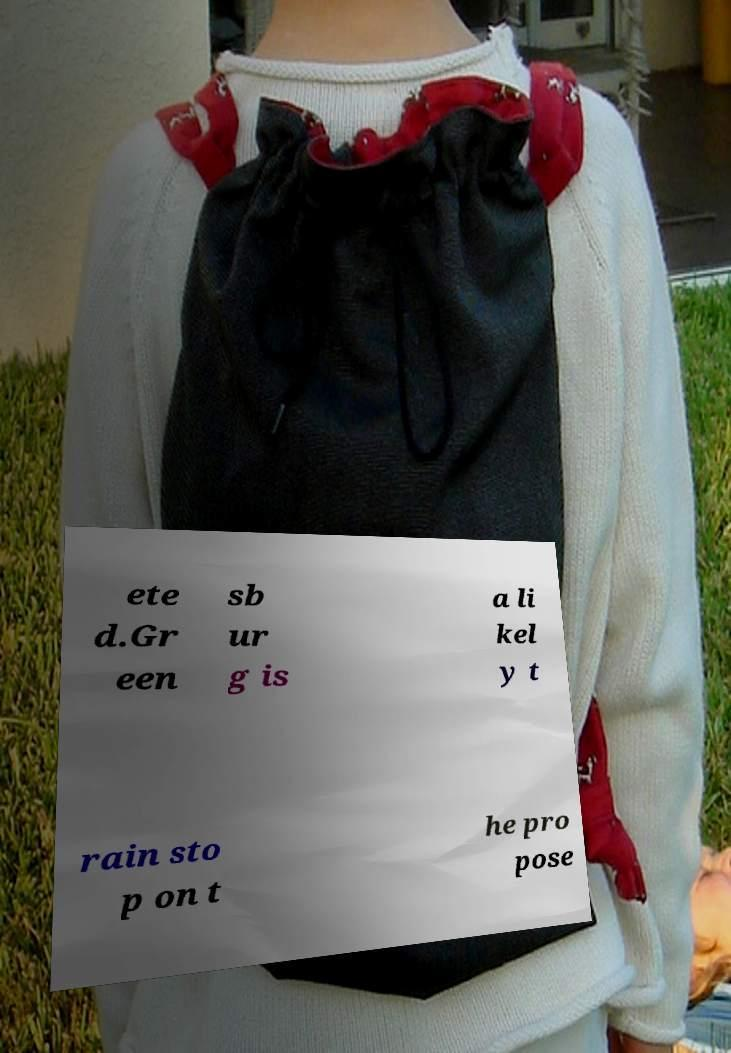There's text embedded in this image that I need extracted. Can you transcribe it verbatim? ete d.Gr een sb ur g is a li kel y t rain sto p on t he pro pose 